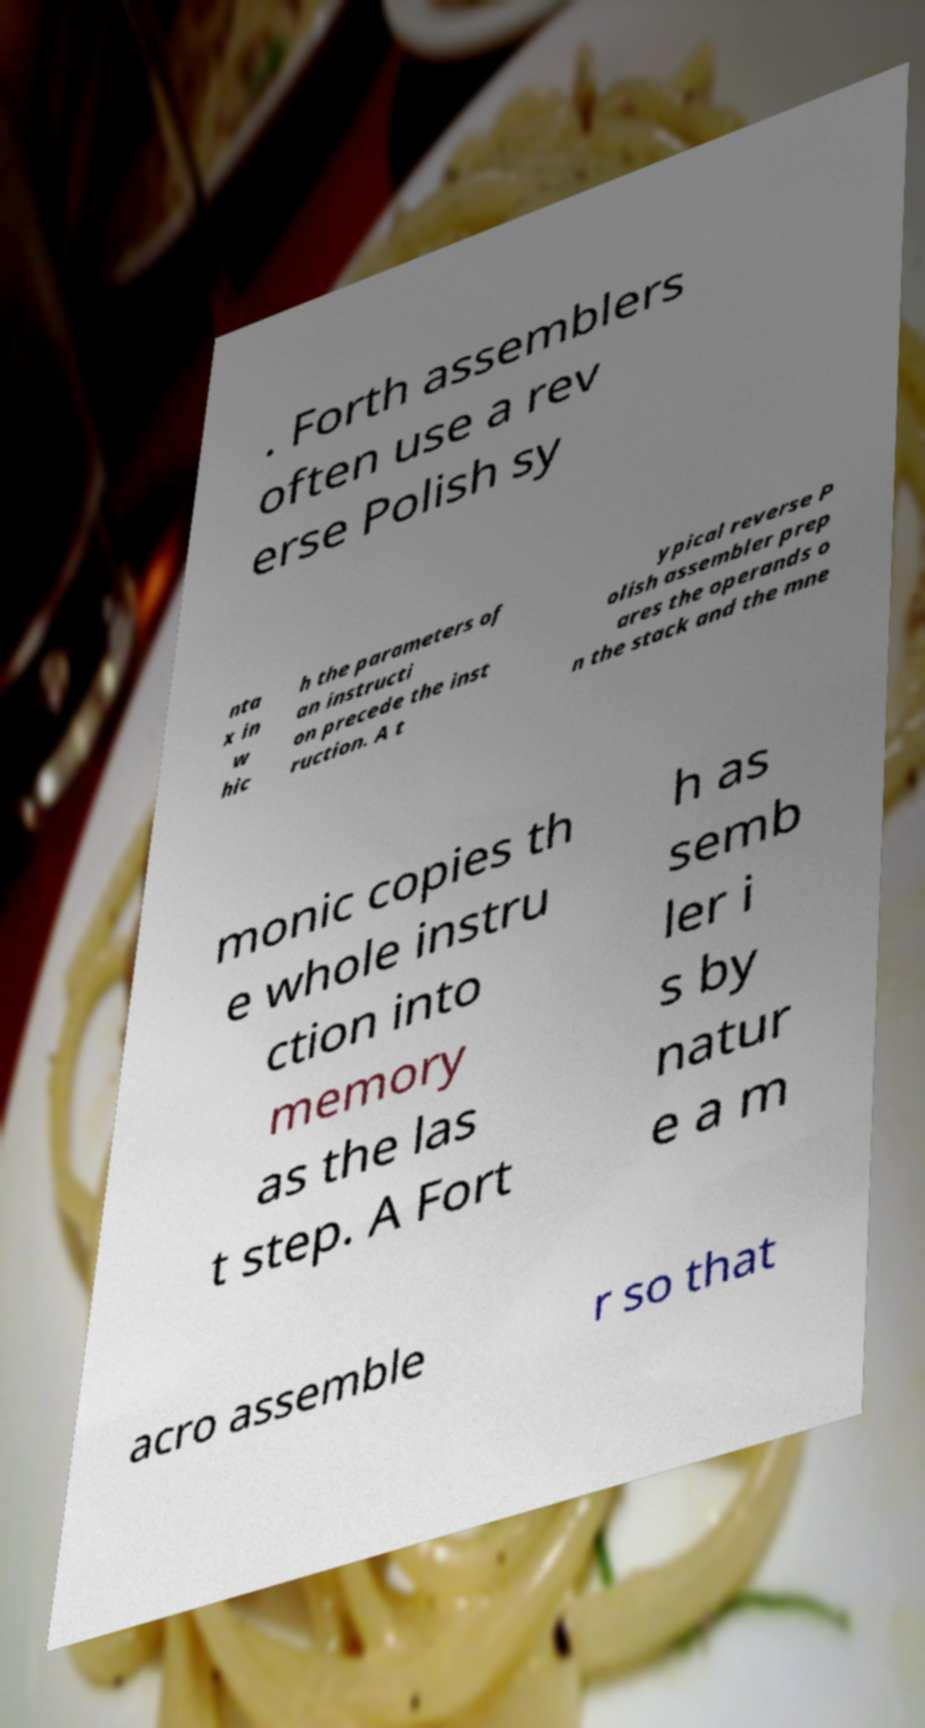There's text embedded in this image that I need extracted. Can you transcribe it verbatim? . Forth assemblers often use a rev erse Polish sy nta x in w hic h the parameters of an instructi on precede the inst ruction. A t ypical reverse P olish assembler prep ares the operands o n the stack and the mne monic copies th e whole instru ction into memory as the las t step. A Fort h as semb ler i s by natur e a m acro assemble r so that 